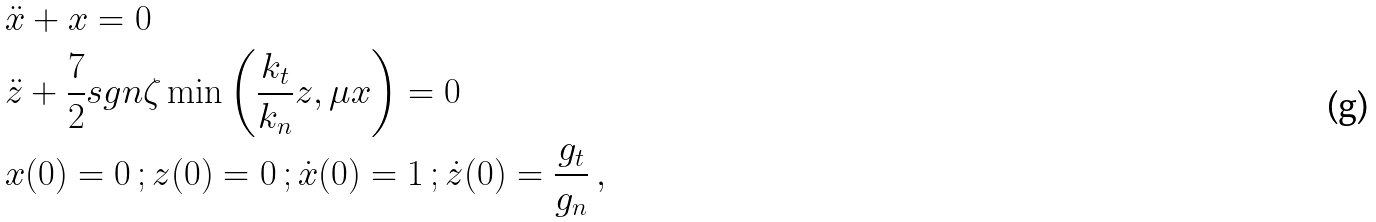Convert formula to latex. <formula><loc_0><loc_0><loc_500><loc_500>& \ddot { x } + x = 0 \\ & \ddot { z } + \frac { 7 } { 2 } s g n \zeta \min \left ( \frac { k _ { t } } { k _ { n } } z , \mu x \right ) = 0 \\ & x ( 0 ) = 0 \, ; z ( 0 ) = 0 \, ; \dot { x } ( 0 ) = 1 \, ; \dot { z } ( 0 ) = \frac { g _ { t } } { g _ { n } } \, ,</formula> 